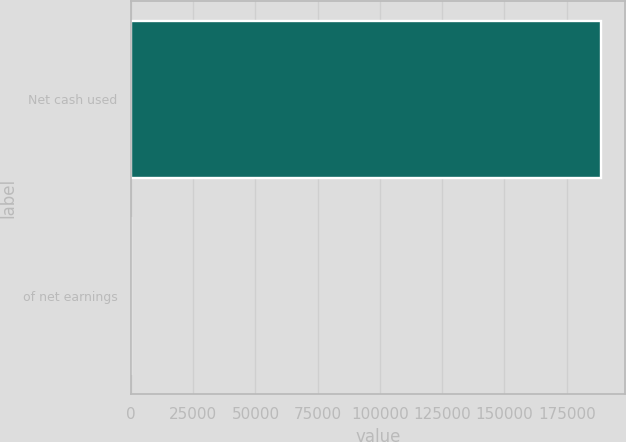Convert chart. <chart><loc_0><loc_0><loc_500><loc_500><bar_chart><fcel>Net cash used<fcel>of net earnings<nl><fcel>188781<fcel>38.2<nl></chart> 